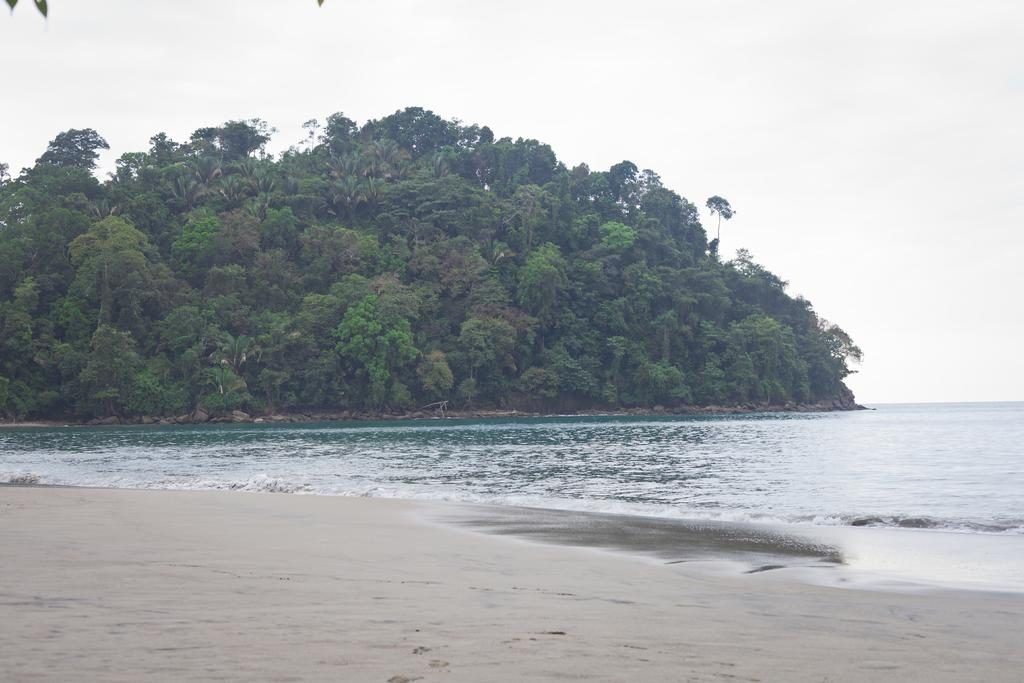What can be seen in the image? There is water visible in the image. What is present in the background of the image? There are trees in the background of the image. What songs are being sung by the trees in the image? There are no songs being sung by the trees in the image, as trees do not have the ability to sing. 